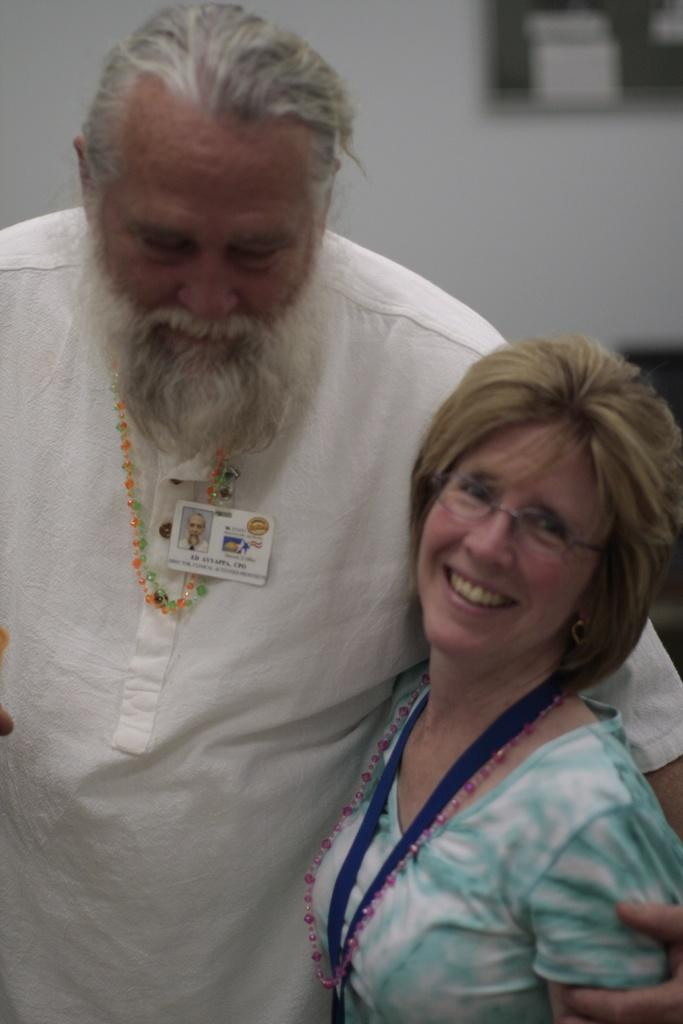Who are the people in the image? There is a man and a lady in the image. What are they wearing that identifies them? Both the man and the lady are wearing ID cards. Can you describe any specific features of one of them? One of them is wearing glasses. What can be seen in the background of the image? There is a wall and other objects visible in the background of the image. Can you tell me how many wings are visible in the image? There are no wings visible in the image. What type of stretch is the lady performing in the image? There is no stretch being performed in the image; the lady is standing still. 